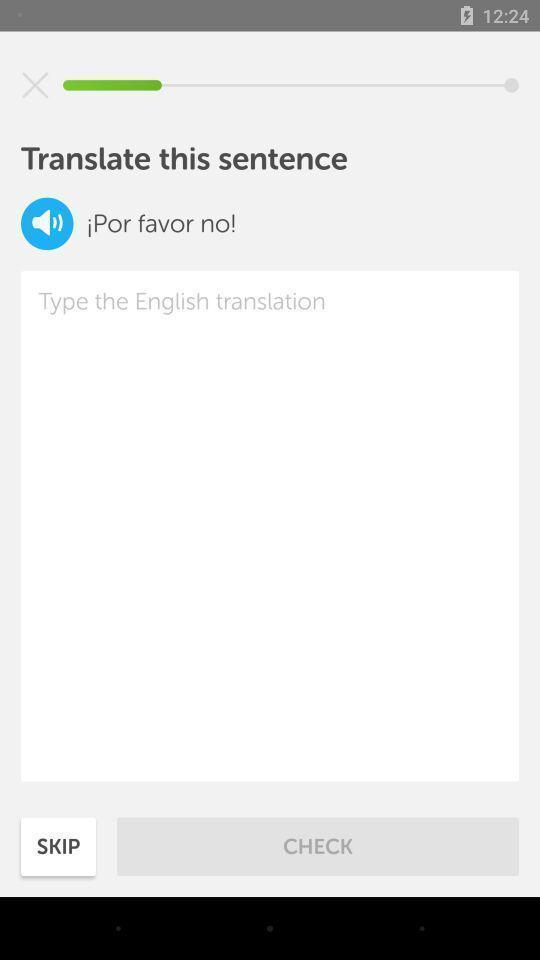Tell me what you see in this picture. Page to translate a sentence to english. 